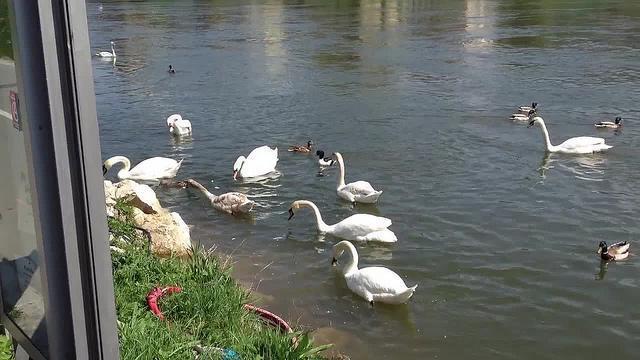How many swans are in this photo?
Give a very brief answer. 9. 